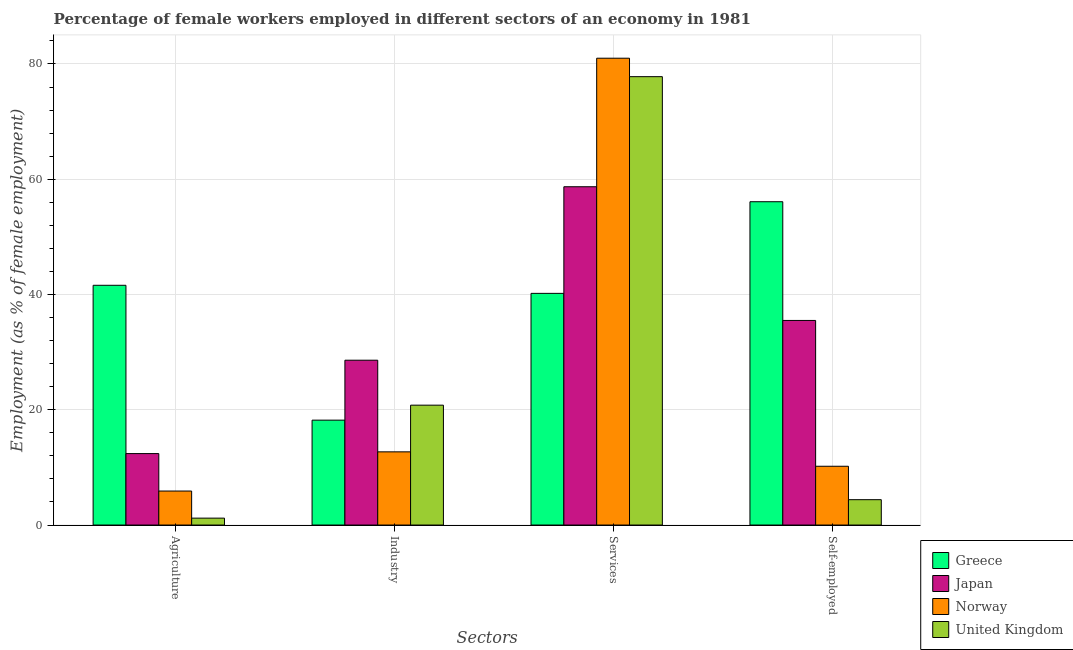How many groups of bars are there?
Offer a very short reply. 4. Are the number of bars per tick equal to the number of legend labels?
Offer a terse response. Yes. Are the number of bars on each tick of the X-axis equal?
Offer a terse response. Yes. How many bars are there on the 4th tick from the right?
Offer a terse response. 4. What is the label of the 2nd group of bars from the left?
Give a very brief answer. Industry. What is the percentage of female workers in services in Greece?
Your answer should be very brief. 40.2. Across all countries, what is the maximum percentage of self employed female workers?
Give a very brief answer. 56.1. Across all countries, what is the minimum percentage of female workers in industry?
Give a very brief answer. 12.7. In which country was the percentage of female workers in agriculture maximum?
Provide a succinct answer. Greece. In which country was the percentage of female workers in agriculture minimum?
Provide a short and direct response. United Kingdom. What is the total percentage of female workers in agriculture in the graph?
Offer a very short reply. 61.1. What is the difference between the percentage of female workers in agriculture in Greece and that in Japan?
Ensure brevity in your answer.  29.2. What is the difference between the percentage of female workers in industry in Greece and the percentage of self employed female workers in Japan?
Offer a very short reply. -17.3. What is the average percentage of female workers in industry per country?
Ensure brevity in your answer.  20.08. What is the difference between the percentage of female workers in agriculture and percentage of female workers in industry in Greece?
Offer a very short reply. 23.4. What is the ratio of the percentage of female workers in industry in Japan to that in Norway?
Ensure brevity in your answer.  2.25. Is the percentage of female workers in industry in United Kingdom less than that in Norway?
Provide a short and direct response. No. Is the difference between the percentage of female workers in services in United Kingdom and Japan greater than the difference between the percentage of self employed female workers in United Kingdom and Japan?
Give a very brief answer. Yes. What is the difference between the highest and the second highest percentage of female workers in industry?
Provide a succinct answer. 7.8. What is the difference between the highest and the lowest percentage of female workers in industry?
Your response must be concise. 15.9. What does the 3rd bar from the left in Agriculture represents?
Provide a succinct answer. Norway. What does the 4th bar from the right in Agriculture represents?
Your answer should be compact. Greece. Are all the bars in the graph horizontal?
Give a very brief answer. No. How many countries are there in the graph?
Keep it short and to the point. 4. What is the difference between two consecutive major ticks on the Y-axis?
Offer a very short reply. 20. Are the values on the major ticks of Y-axis written in scientific E-notation?
Offer a terse response. No. Does the graph contain any zero values?
Ensure brevity in your answer.  No. How many legend labels are there?
Provide a succinct answer. 4. What is the title of the graph?
Your answer should be very brief. Percentage of female workers employed in different sectors of an economy in 1981. Does "French Polynesia" appear as one of the legend labels in the graph?
Your answer should be compact. No. What is the label or title of the X-axis?
Keep it short and to the point. Sectors. What is the label or title of the Y-axis?
Make the answer very short. Employment (as % of female employment). What is the Employment (as % of female employment) of Greece in Agriculture?
Give a very brief answer. 41.6. What is the Employment (as % of female employment) of Japan in Agriculture?
Your answer should be compact. 12.4. What is the Employment (as % of female employment) of Norway in Agriculture?
Provide a short and direct response. 5.9. What is the Employment (as % of female employment) in United Kingdom in Agriculture?
Provide a succinct answer. 1.2. What is the Employment (as % of female employment) in Greece in Industry?
Provide a short and direct response. 18.2. What is the Employment (as % of female employment) in Japan in Industry?
Make the answer very short. 28.6. What is the Employment (as % of female employment) in Norway in Industry?
Your answer should be very brief. 12.7. What is the Employment (as % of female employment) in United Kingdom in Industry?
Give a very brief answer. 20.8. What is the Employment (as % of female employment) in Greece in Services?
Your answer should be compact. 40.2. What is the Employment (as % of female employment) in Japan in Services?
Your answer should be very brief. 58.7. What is the Employment (as % of female employment) in Norway in Services?
Give a very brief answer. 81. What is the Employment (as % of female employment) in United Kingdom in Services?
Ensure brevity in your answer.  77.8. What is the Employment (as % of female employment) in Greece in Self-employed?
Keep it short and to the point. 56.1. What is the Employment (as % of female employment) of Japan in Self-employed?
Provide a short and direct response. 35.5. What is the Employment (as % of female employment) of Norway in Self-employed?
Offer a terse response. 10.2. What is the Employment (as % of female employment) in United Kingdom in Self-employed?
Give a very brief answer. 4.4. Across all Sectors, what is the maximum Employment (as % of female employment) in Greece?
Give a very brief answer. 56.1. Across all Sectors, what is the maximum Employment (as % of female employment) of Japan?
Your answer should be very brief. 58.7. Across all Sectors, what is the maximum Employment (as % of female employment) of United Kingdom?
Make the answer very short. 77.8. Across all Sectors, what is the minimum Employment (as % of female employment) in Greece?
Make the answer very short. 18.2. Across all Sectors, what is the minimum Employment (as % of female employment) in Japan?
Provide a succinct answer. 12.4. Across all Sectors, what is the minimum Employment (as % of female employment) in Norway?
Provide a succinct answer. 5.9. Across all Sectors, what is the minimum Employment (as % of female employment) of United Kingdom?
Offer a very short reply. 1.2. What is the total Employment (as % of female employment) in Greece in the graph?
Give a very brief answer. 156.1. What is the total Employment (as % of female employment) of Japan in the graph?
Offer a terse response. 135.2. What is the total Employment (as % of female employment) of Norway in the graph?
Your answer should be very brief. 109.8. What is the total Employment (as % of female employment) of United Kingdom in the graph?
Ensure brevity in your answer.  104.2. What is the difference between the Employment (as % of female employment) in Greece in Agriculture and that in Industry?
Provide a short and direct response. 23.4. What is the difference between the Employment (as % of female employment) of Japan in Agriculture and that in Industry?
Ensure brevity in your answer.  -16.2. What is the difference between the Employment (as % of female employment) of United Kingdom in Agriculture and that in Industry?
Your response must be concise. -19.6. What is the difference between the Employment (as % of female employment) in Greece in Agriculture and that in Services?
Your answer should be very brief. 1.4. What is the difference between the Employment (as % of female employment) of Japan in Agriculture and that in Services?
Your answer should be compact. -46.3. What is the difference between the Employment (as % of female employment) of Norway in Agriculture and that in Services?
Make the answer very short. -75.1. What is the difference between the Employment (as % of female employment) of United Kingdom in Agriculture and that in Services?
Give a very brief answer. -76.6. What is the difference between the Employment (as % of female employment) of Japan in Agriculture and that in Self-employed?
Give a very brief answer. -23.1. What is the difference between the Employment (as % of female employment) of United Kingdom in Agriculture and that in Self-employed?
Your answer should be compact. -3.2. What is the difference between the Employment (as % of female employment) of Japan in Industry and that in Services?
Offer a very short reply. -30.1. What is the difference between the Employment (as % of female employment) of Norway in Industry and that in Services?
Make the answer very short. -68.3. What is the difference between the Employment (as % of female employment) in United Kingdom in Industry and that in Services?
Ensure brevity in your answer.  -57. What is the difference between the Employment (as % of female employment) in Greece in Industry and that in Self-employed?
Provide a short and direct response. -37.9. What is the difference between the Employment (as % of female employment) of United Kingdom in Industry and that in Self-employed?
Make the answer very short. 16.4. What is the difference between the Employment (as % of female employment) in Greece in Services and that in Self-employed?
Your answer should be very brief. -15.9. What is the difference between the Employment (as % of female employment) in Japan in Services and that in Self-employed?
Your answer should be very brief. 23.2. What is the difference between the Employment (as % of female employment) in Norway in Services and that in Self-employed?
Give a very brief answer. 70.8. What is the difference between the Employment (as % of female employment) of United Kingdom in Services and that in Self-employed?
Offer a very short reply. 73.4. What is the difference between the Employment (as % of female employment) of Greece in Agriculture and the Employment (as % of female employment) of Japan in Industry?
Offer a terse response. 13. What is the difference between the Employment (as % of female employment) in Greece in Agriculture and the Employment (as % of female employment) in Norway in Industry?
Offer a terse response. 28.9. What is the difference between the Employment (as % of female employment) in Greece in Agriculture and the Employment (as % of female employment) in United Kingdom in Industry?
Provide a short and direct response. 20.8. What is the difference between the Employment (as % of female employment) in Norway in Agriculture and the Employment (as % of female employment) in United Kingdom in Industry?
Offer a terse response. -14.9. What is the difference between the Employment (as % of female employment) of Greece in Agriculture and the Employment (as % of female employment) of Japan in Services?
Keep it short and to the point. -17.1. What is the difference between the Employment (as % of female employment) in Greece in Agriculture and the Employment (as % of female employment) in Norway in Services?
Provide a succinct answer. -39.4. What is the difference between the Employment (as % of female employment) in Greece in Agriculture and the Employment (as % of female employment) in United Kingdom in Services?
Provide a short and direct response. -36.2. What is the difference between the Employment (as % of female employment) of Japan in Agriculture and the Employment (as % of female employment) of Norway in Services?
Give a very brief answer. -68.6. What is the difference between the Employment (as % of female employment) in Japan in Agriculture and the Employment (as % of female employment) in United Kingdom in Services?
Offer a terse response. -65.4. What is the difference between the Employment (as % of female employment) of Norway in Agriculture and the Employment (as % of female employment) of United Kingdom in Services?
Ensure brevity in your answer.  -71.9. What is the difference between the Employment (as % of female employment) of Greece in Agriculture and the Employment (as % of female employment) of Japan in Self-employed?
Offer a very short reply. 6.1. What is the difference between the Employment (as % of female employment) of Greece in Agriculture and the Employment (as % of female employment) of Norway in Self-employed?
Your response must be concise. 31.4. What is the difference between the Employment (as % of female employment) of Greece in Agriculture and the Employment (as % of female employment) of United Kingdom in Self-employed?
Offer a terse response. 37.2. What is the difference between the Employment (as % of female employment) of Japan in Agriculture and the Employment (as % of female employment) of United Kingdom in Self-employed?
Keep it short and to the point. 8. What is the difference between the Employment (as % of female employment) of Norway in Agriculture and the Employment (as % of female employment) of United Kingdom in Self-employed?
Provide a short and direct response. 1.5. What is the difference between the Employment (as % of female employment) in Greece in Industry and the Employment (as % of female employment) in Japan in Services?
Your response must be concise. -40.5. What is the difference between the Employment (as % of female employment) of Greece in Industry and the Employment (as % of female employment) of Norway in Services?
Offer a terse response. -62.8. What is the difference between the Employment (as % of female employment) in Greece in Industry and the Employment (as % of female employment) in United Kingdom in Services?
Your response must be concise. -59.6. What is the difference between the Employment (as % of female employment) in Japan in Industry and the Employment (as % of female employment) in Norway in Services?
Provide a succinct answer. -52.4. What is the difference between the Employment (as % of female employment) of Japan in Industry and the Employment (as % of female employment) of United Kingdom in Services?
Your response must be concise. -49.2. What is the difference between the Employment (as % of female employment) of Norway in Industry and the Employment (as % of female employment) of United Kingdom in Services?
Ensure brevity in your answer.  -65.1. What is the difference between the Employment (as % of female employment) in Greece in Industry and the Employment (as % of female employment) in Japan in Self-employed?
Give a very brief answer. -17.3. What is the difference between the Employment (as % of female employment) in Greece in Industry and the Employment (as % of female employment) in Norway in Self-employed?
Keep it short and to the point. 8. What is the difference between the Employment (as % of female employment) in Greece in Industry and the Employment (as % of female employment) in United Kingdom in Self-employed?
Give a very brief answer. 13.8. What is the difference between the Employment (as % of female employment) of Japan in Industry and the Employment (as % of female employment) of Norway in Self-employed?
Your response must be concise. 18.4. What is the difference between the Employment (as % of female employment) of Japan in Industry and the Employment (as % of female employment) of United Kingdom in Self-employed?
Keep it short and to the point. 24.2. What is the difference between the Employment (as % of female employment) of Norway in Industry and the Employment (as % of female employment) of United Kingdom in Self-employed?
Make the answer very short. 8.3. What is the difference between the Employment (as % of female employment) of Greece in Services and the Employment (as % of female employment) of United Kingdom in Self-employed?
Give a very brief answer. 35.8. What is the difference between the Employment (as % of female employment) of Japan in Services and the Employment (as % of female employment) of Norway in Self-employed?
Provide a succinct answer. 48.5. What is the difference between the Employment (as % of female employment) of Japan in Services and the Employment (as % of female employment) of United Kingdom in Self-employed?
Provide a succinct answer. 54.3. What is the difference between the Employment (as % of female employment) of Norway in Services and the Employment (as % of female employment) of United Kingdom in Self-employed?
Offer a terse response. 76.6. What is the average Employment (as % of female employment) of Greece per Sectors?
Offer a terse response. 39.02. What is the average Employment (as % of female employment) of Japan per Sectors?
Offer a terse response. 33.8. What is the average Employment (as % of female employment) of Norway per Sectors?
Your response must be concise. 27.45. What is the average Employment (as % of female employment) of United Kingdom per Sectors?
Your response must be concise. 26.05. What is the difference between the Employment (as % of female employment) in Greece and Employment (as % of female employment) in Japan in Agriculture?
Your answer should be compact. 29.2. What is the difference between the Employment (as % of female employment) of Greece and Employment (as % of female employment) of Norway in Agriculture?
Ensure brevity in your answer.  35.7. What is the difference between the Employment (as % of female employment) in Greece and Employment (as % of female employment) in United Kingdom in Agriculture?
Provide a succinct answer. 40.4. What is the difference between the Employment (as % of female employment) of Japan and Employment (as % of female employment) of United Kingdom in Agriculture?
Provide a succinct answer. 11.2. What is the difference between the Employment (as % of female employment) of Norway and Employment (as % of female employment) of United Kingdom in Agriculture?
Your answer should be very brief. 4.7. What is the difference between the Employment (as % of female employment) of Greece and Employment (as % of female employment) of Norway in Industry?
Ensure brevity in your answer.  5.5. What is the difference between the Employment (as % of female employment) in Greece and Employment (as % of female employment) in United Kingdom in Industry?
Your response must be concise. -2.6. What is the difference between the Employment (as % of female employment) of Greece and Employment (as % of female employment) of Japan in Services?
Offer a very short reply. -18.5. What is the difference between the Employment (as % of female employment) of Greece and Employment (as % of female employment) of Norway in Services?
Your answer should be very brief. -40.8. What is the difference between the Employment (as % of female employment) in Greece and Employment (as % of female employment) in United Kingdom in Services?
Provide a succinct answer. -37.6. What is the difference between the Employment (as % of female employment) in Japan and Employment (as % of female employment) in Norway in Services?
Provide a succinct answer. -22.3. What is the difference between the Employment (as % of female employment) in Japan and Employment (as % of female employment) in United Kingdom in Services?
Give a very brief answer. -19.1. What is the difference between the Employment (as % of female employment) in Greece and Employment (as % of female employment) in Japan in Self-employed?
Ensure brevity in your answer.  20.6. What is the difference between the Employment (as % of female employment) in Greece and Employment (as % of female employment) in Norway in Self-employed?
Provide a short and direct response. 45.9. What is the difference between the Employment (as % of female employment) of Greece and Employment (as % of female employment) of United Kingdom in Self-employed?
Your response must be concise. 51.7. What is the difference between the Employment (as % of female employment) in Japan and Employment (as % of female employment) in Norway in Self-employed?
Your response must be concise. 25.3. What is the difference between the Employment (as % of female employment) of Japan and Employment (as % of female employment) of United Kingdom in Self-employed?
Your answer should be very brief. 31.1. What is the ratio of the Employment (as % of female employment) of Greece in Agriculture to that in Industry?
Provide a succinct answer. 2.29. What is the ratio of the Employment (as % of female employment) in Japan in Agriculture to that in Industry?
Offer a terse response. 0.43. What is the ratio of the Employment (as % of female employment) in Norway in Agriculture to that in Industry?
Your response must be concise. 0.46. What is the ratio of the Employment (as % of female employment) of United Kingdom in Agriculture to that in Industry?
Make the answer very short. 0.06. What is the ratio of the Employment (as % of female employment) in Greece in Agriculture to that in Services?
Keep it short and to the point. 1.03. What is the ratio of the Employment (as % of female employment) of Japan in Agriculture to that in Services?
Ensure brevity in your answer.  0.21. What is the ratio of the Employment (as % of female employment) of Norway in Agriculture to that in Services?
Make the answer very short. 0.07. What is the ratio of the Employment (as % of female employment) of United Kingdom in Agriculture to that in Services?
Make the answer very short. 0.02. What is the ratio of the Employment (as % of female employment) in Greece in Agriculture to that in Self-employed?
Provide a succinct answer. 0.74. What is the ratio of the Employment (as % of female employment) in Japan in Agriculture to that in Self-employed?
Provide a succinct answer. 0.35. What is the ratio of the Employment (as % of female employment) of Norway in Agriculture to that in Self-employed?
Provide a short and direct response. 0.58. What is the ratio of the Employment (as % of female employment) of United Kingdom in Agriculture to that in Self-employed?
Keep it short and to the point. 0.27. What is the ratio of the Employment (as % of female employment) of Greece in Industry to that in Services?
Give a very brief answer. 0.45. What is the ratio of the Employment (as % of female employment) in Japan in Industry to that in Services?
Make the answer very short. 0.49. What is the ratio of the Employment (as % of female employment) of Norway in Industry to that in Services?
Ensure brevity in your answer.  0.16. What is the ratio of the Employment (as % of female employment) of United Kingdom in Industry to that in Services?
Your answer should be compact. 0.27. What is the ratio of the Employment (as % of female employment) in Greece in Industry to that in Self-employed?
Your response must be concise. 0.32. What is the ratio of the Employment (as % of female employment) of Japan in Industry to that in Self-employed?
Your answer should be compact. 0.81. What is the ratio of the Employment (as % of female employment) in Norway in Industry to that in Self-employed?
Keep it short and to the point. 1.25. What is the ratio of the Employment (as % of female employment) of United Kingdom in Industry to that in Self-employed?
Your response must be concise. 4.73. What is the ratio of the Employment (as % of female employment) in Greece in Services to that in Self-employed?
Provide a succinct answer. 0.72. What is the ratio of the Employment (as % of female employment) in Japan in Services to that in Self-employed?
Your answer should be compact. 1.65. What is the ratio of the Employment (as % of female employment) in Norway in Services to that in Self-employed?
Provide a short and direct response. 7.94. What is the ratio of the Employment (as % of female employment) of United Kingdom in Services to that in Self-employed?
Offer a terse response. 17.68. What is the difference between the highest and the second highest Employment (as % of female employment) in Greece?
Ensure brevity in your answer.  14.5. What is the difference between the highest and the second highest Employment (as % of female employment) in Japan?
Keep it short and to the point. 23.2. What is the difference between the highest and the second highest Employment (as % of female employment) of Norway?
Offer a terse response. 68.3. What is the difference between the highest and the lowest Employment (as % of female employment) of Greece?
Your response must be concise. 37.9. What is the difference between the highest and the lowest Employment (as % of female employment) of Japan?
Give a very brief answer. 46.3. What is the difference between the highest and the lowest Employment (as % of female employment) of Norway?
Ensure brevity in your answer.  75.1. What is the difference between the highest and the lowest Employment (as % of female employment) in United Kingdom?
Ensure brevity in your answer.  76.6. 